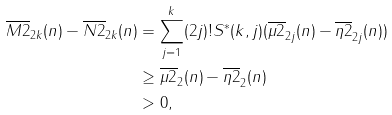Convert formula to latex. <formula><loc_0><loc_0><loc_500><loc_500>\overline { M 2 } _ { 2 k } ( n ) - \overline { N 2 } _ { 2 k } ( n ) & = \sum _ { j = 1 } ^ { k } ( 2 j ) ! S ^ { * } ( k , j ) ( \overline { \mu 2 } _ { 2 j } ( n ) - \overline { \eta 2 } _ { 2 j } ( n ) ) \\ & \geq \overline { \mu 2 } _ { 2 } ( n ) - \overline { \eta 2 } _ { 2 } ( n ) \\ & > 0 ,</formula> 